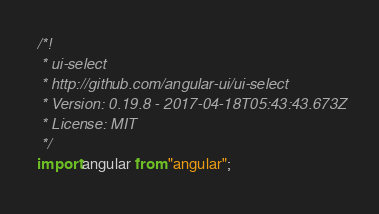<code> <loc_0><loc_0><loc_500><loc_500><_JavaScript_>/*!
 * ui-select
 * http://github.com/angular-ui/ui-select
 * Version: 0.19.8 - 2017-04-18T05:43:43.673Z
 * License: MIT
 */
import angular from "angular";</code> 